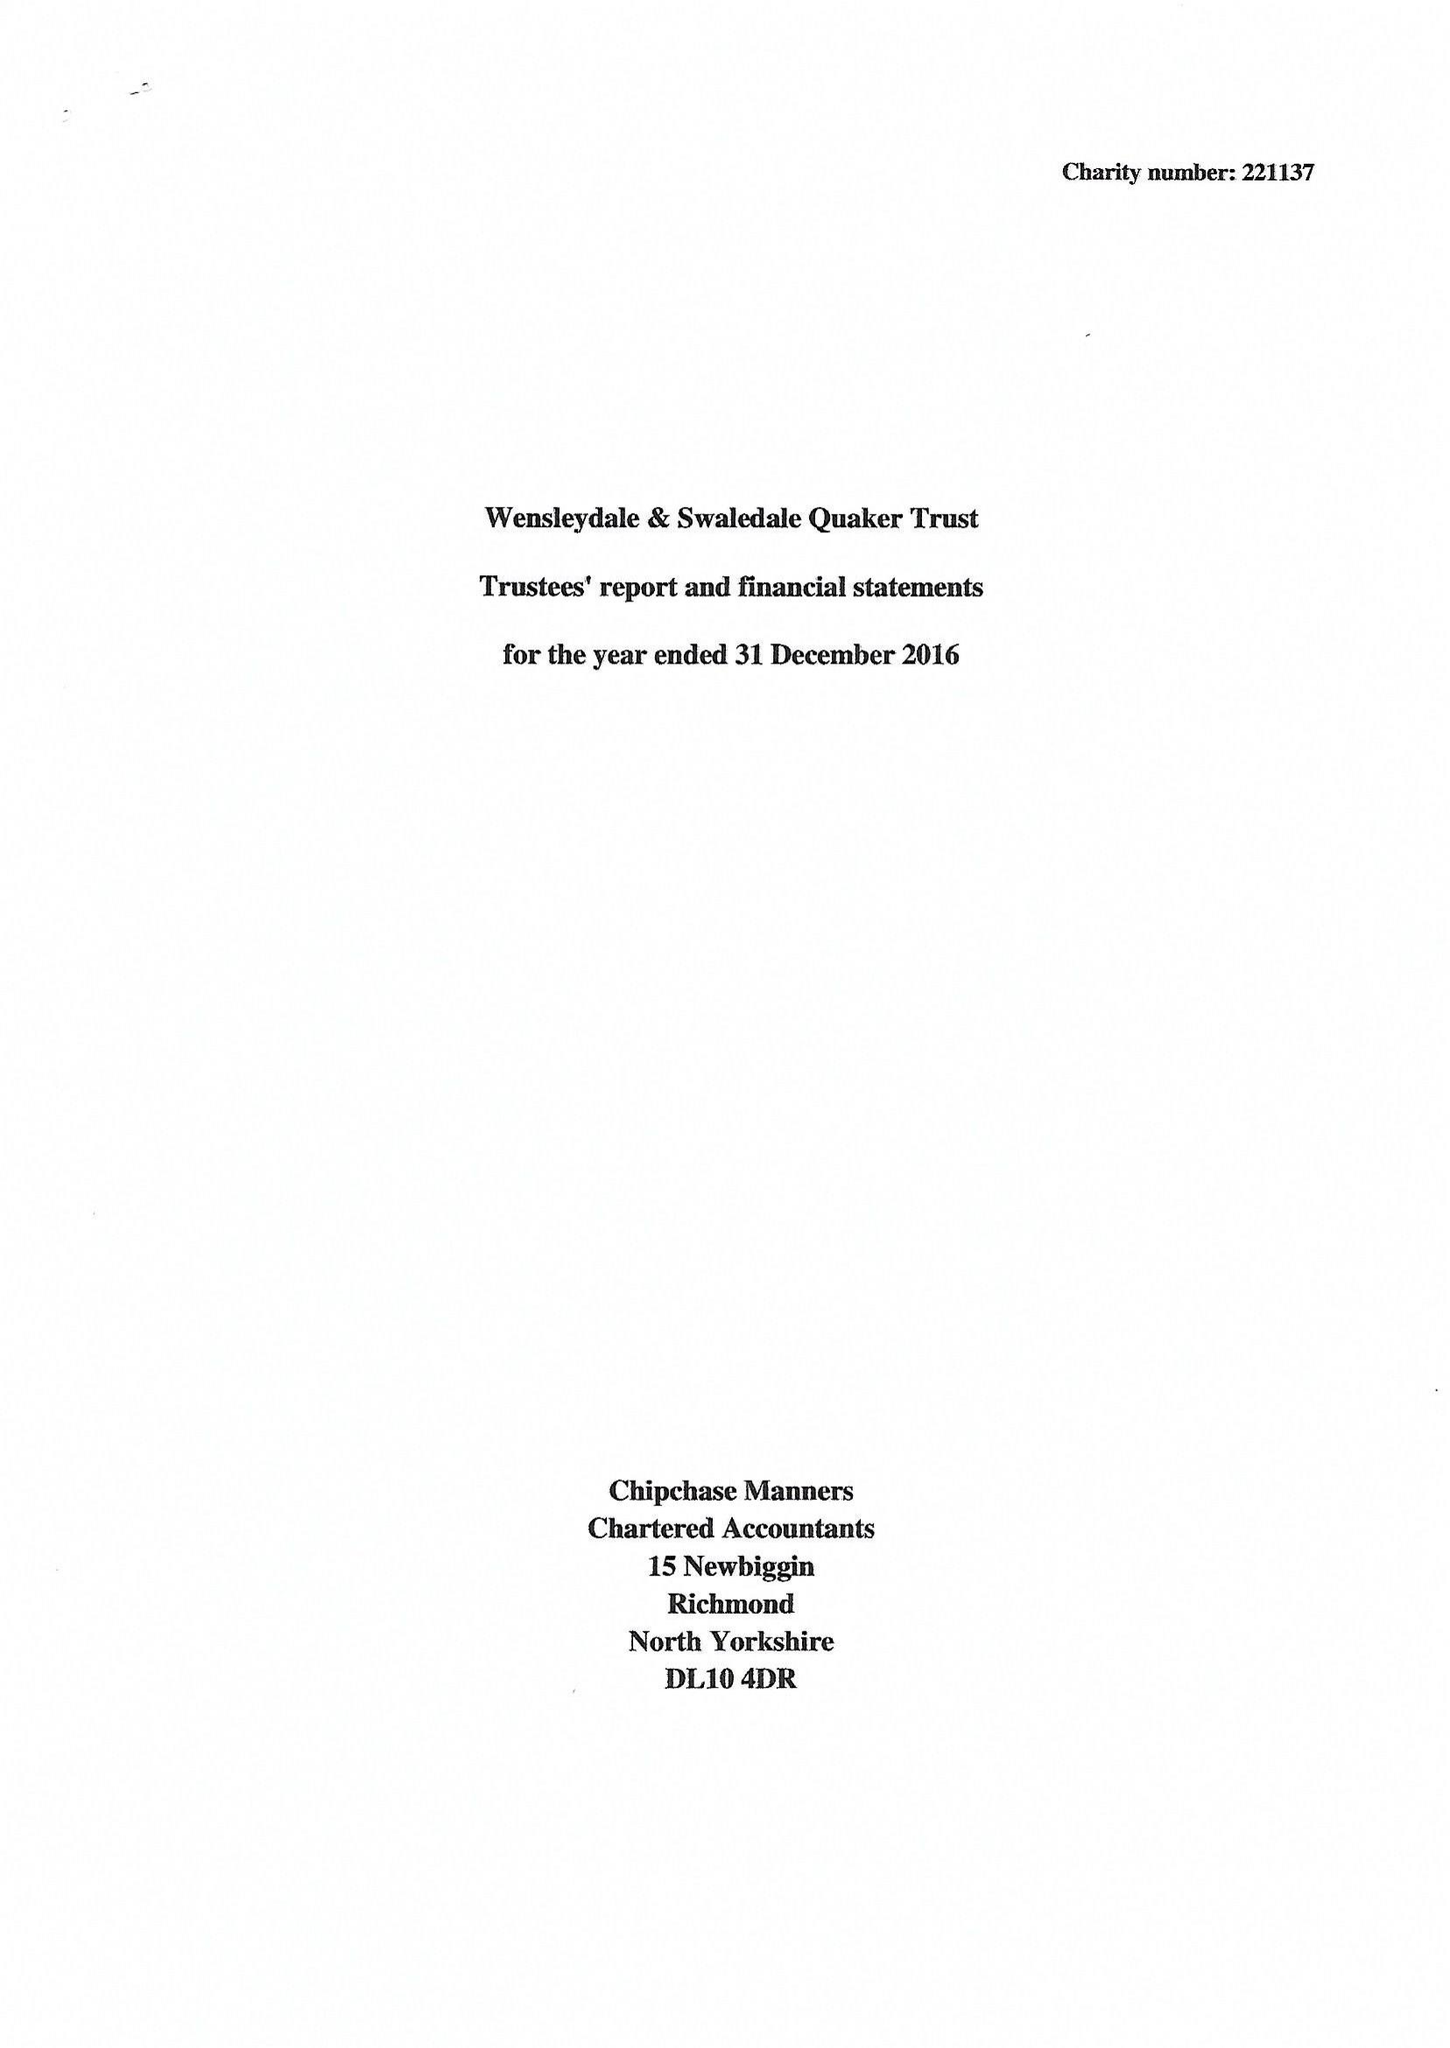What is the value for the address__post_town?
Answer the question using a single word or phrase. LEYBURN 